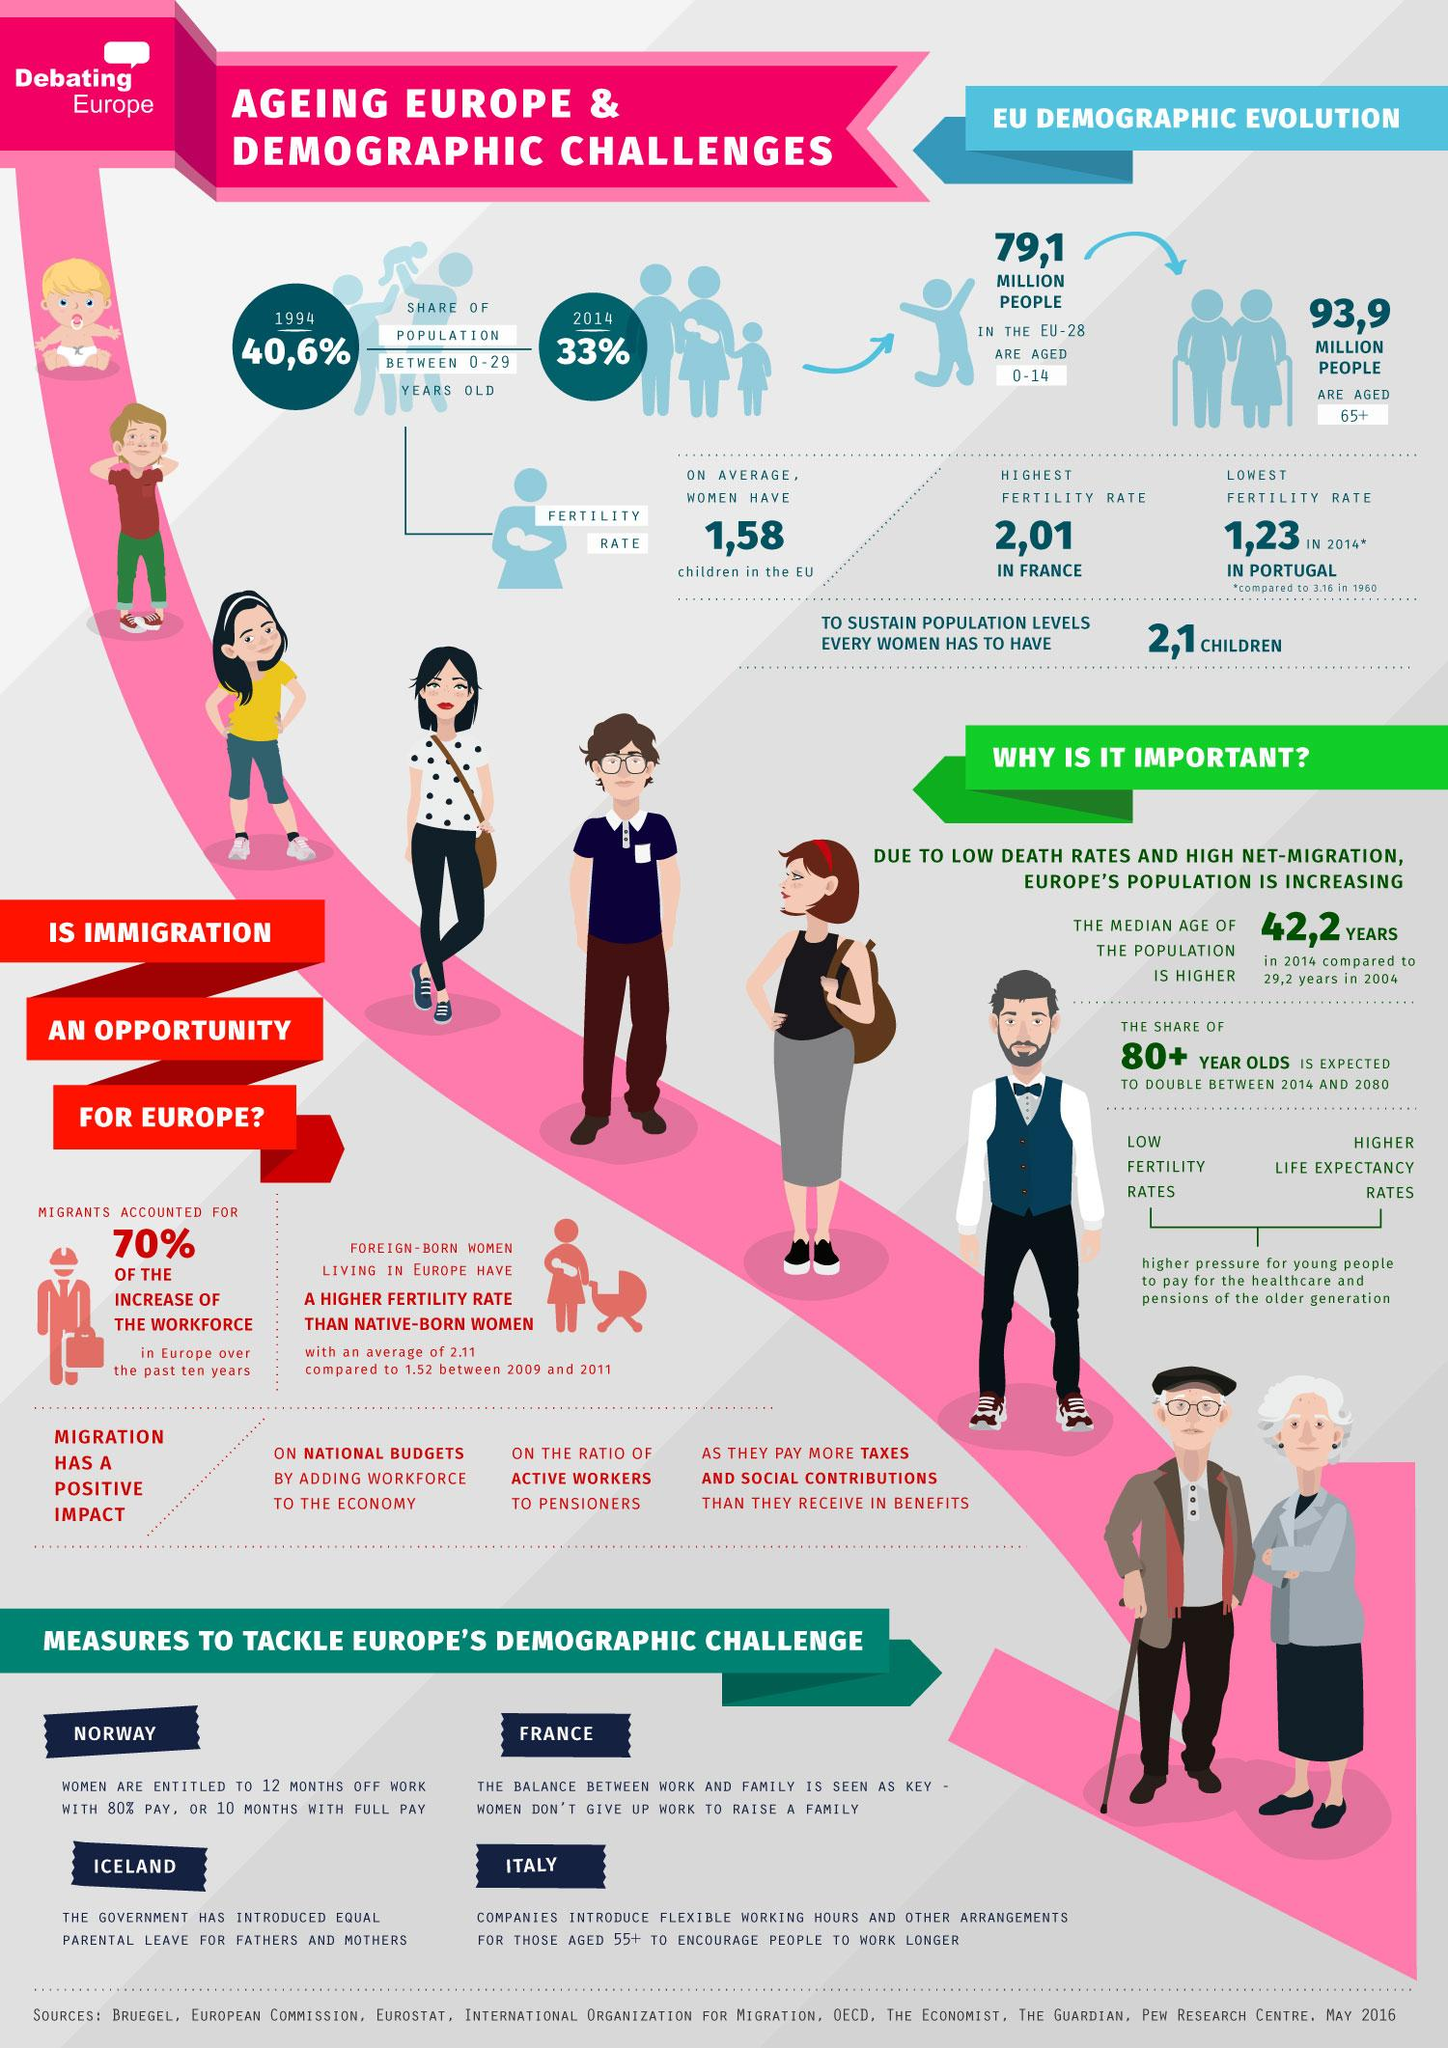Specify some key components in this picture. The country with the lowest fertility rate is Portugal. France has the highest fertility rate among all countries. 